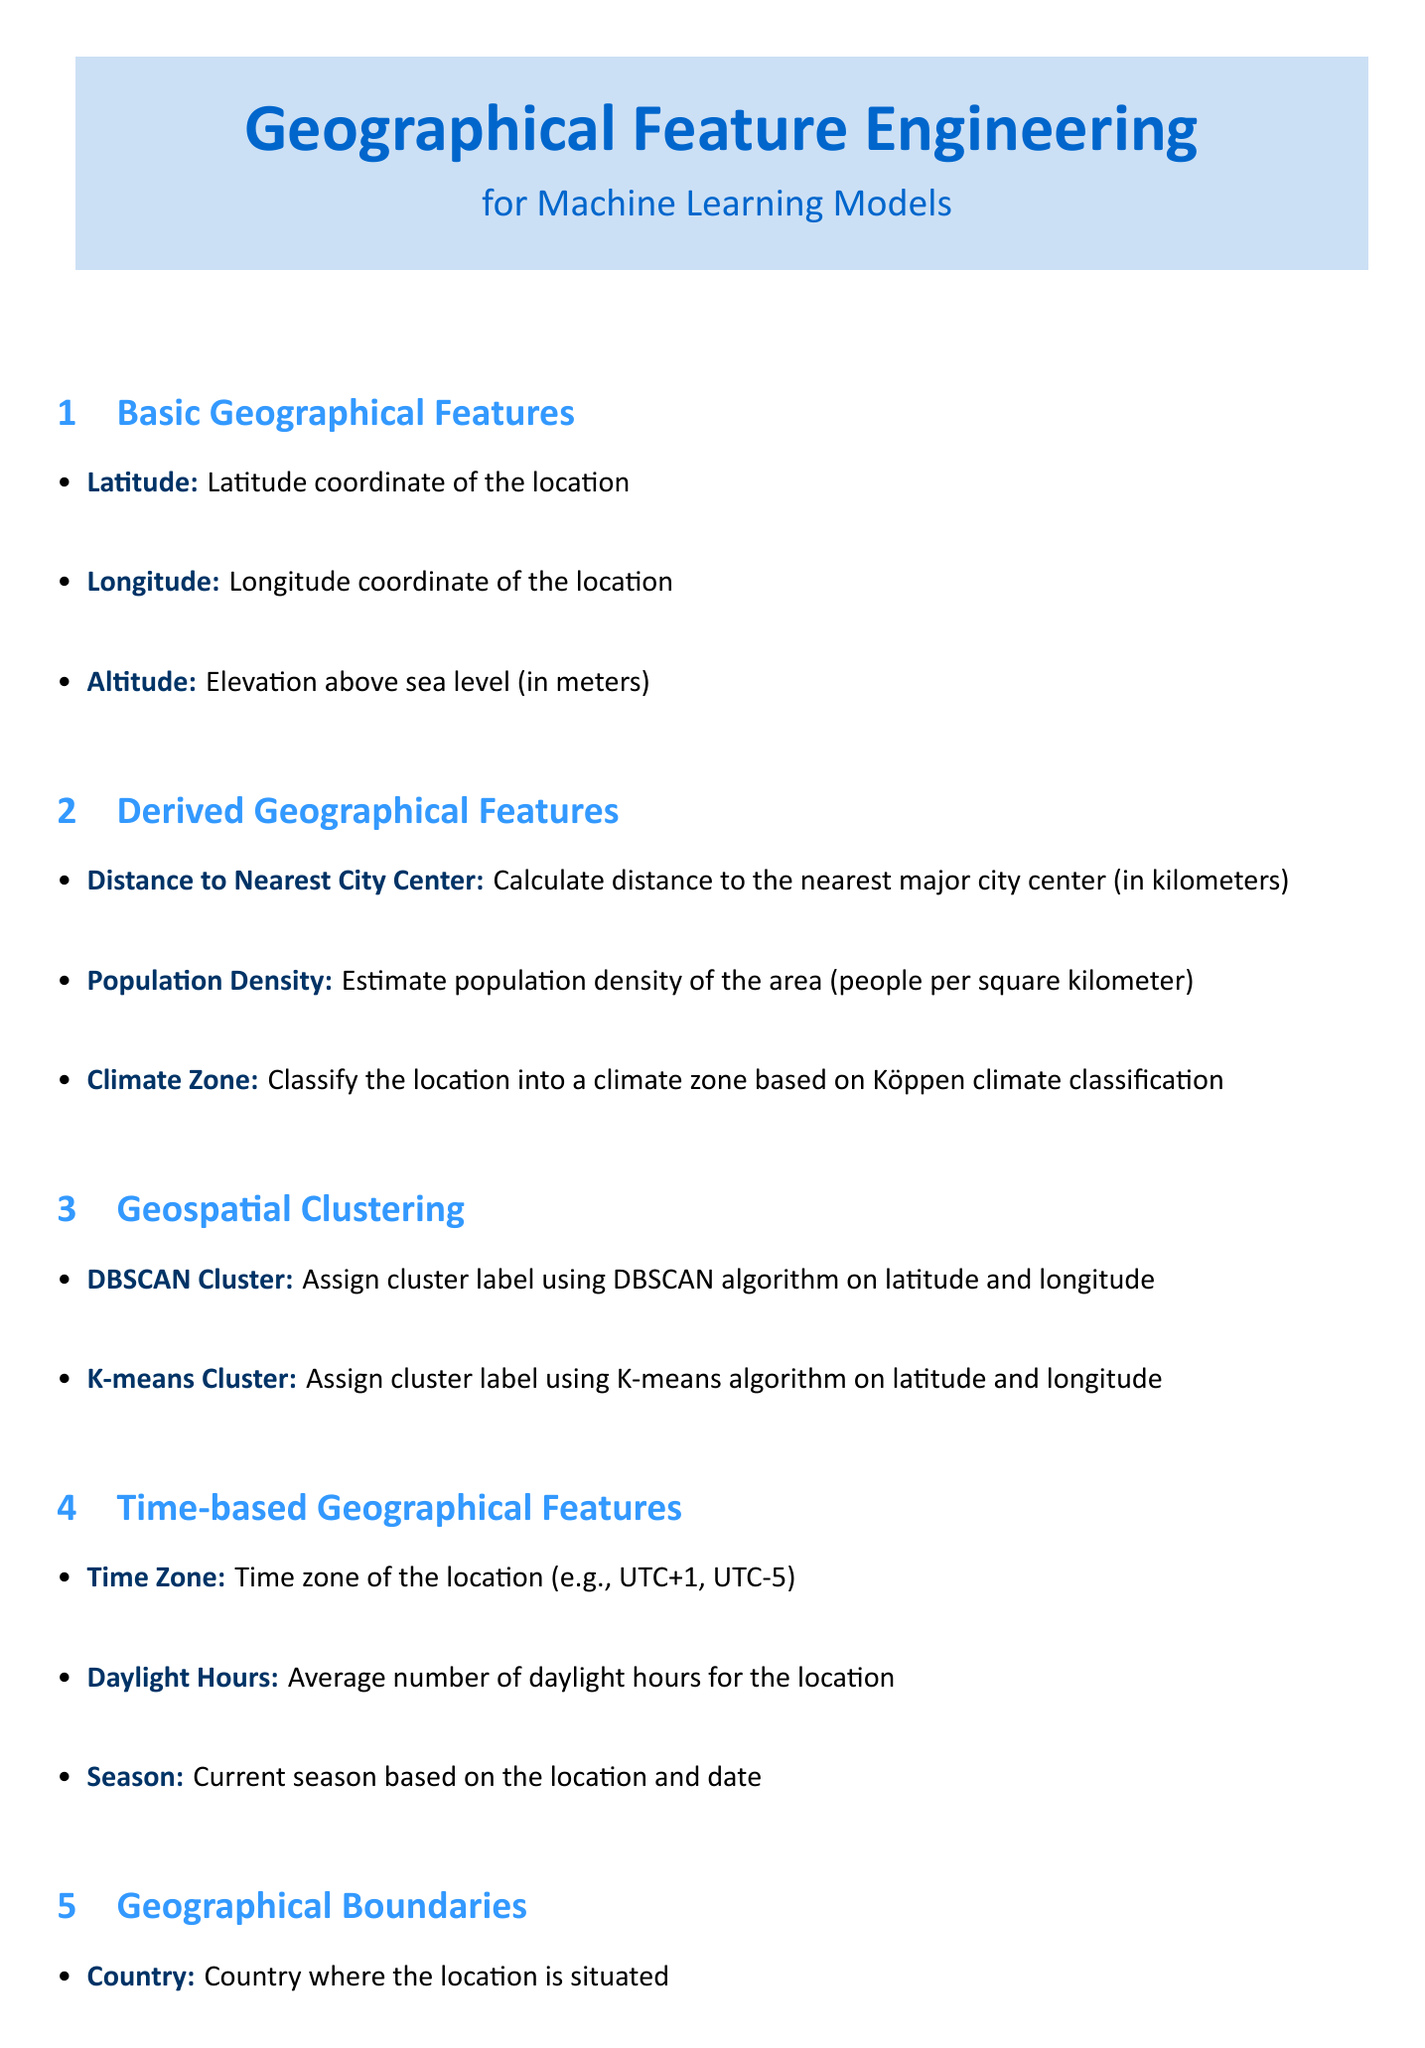What are the basic geographical features listed? The document lists Latitude, Longitude, and Altitude under basic geographical features.
Answer: Latitude, Longitude, Altitude What is the distance to the nearest city center measured in? The distance to the nearest city center is measured in kilometers.
Answer: kilometers What climate zone options are provided in the derived geographical features? The document provides options for the climate zone in the derived geographical features section.
Answer: Tropical, Dry, Temperate, Continental, Polar What does the DBSCAN Cluster field represent? The DBSCAN Cluster field assigns a cluster label using the DBSCAN algorithm on latitude and longitude.
Answer: Cluster label What are the predominant terrain types mentioned in the geographical context? The document specifies multiple terrain types in the geographical context section.
Answer: Urban, Suburban, Rural, Forest, Mountain, Desert, Coastal How is spatial lag calculated? Spatial lag is calculated using inverse distance weighting according to the document.
Answer: Inverse distance weighting What section includes the postal code? The postal code is included in the geographical boundaries section of the document.
Answer: Geographical Boundaries What is the average unit for daylight hours? The average unit for daylight hours in the document is numeric.
Answer: numeric What statistical analysis is associated with spatial autocorrelation? The document associates Moran's I Statistic with spatial autocorrelation.
Answer: Moran's I Statistic 